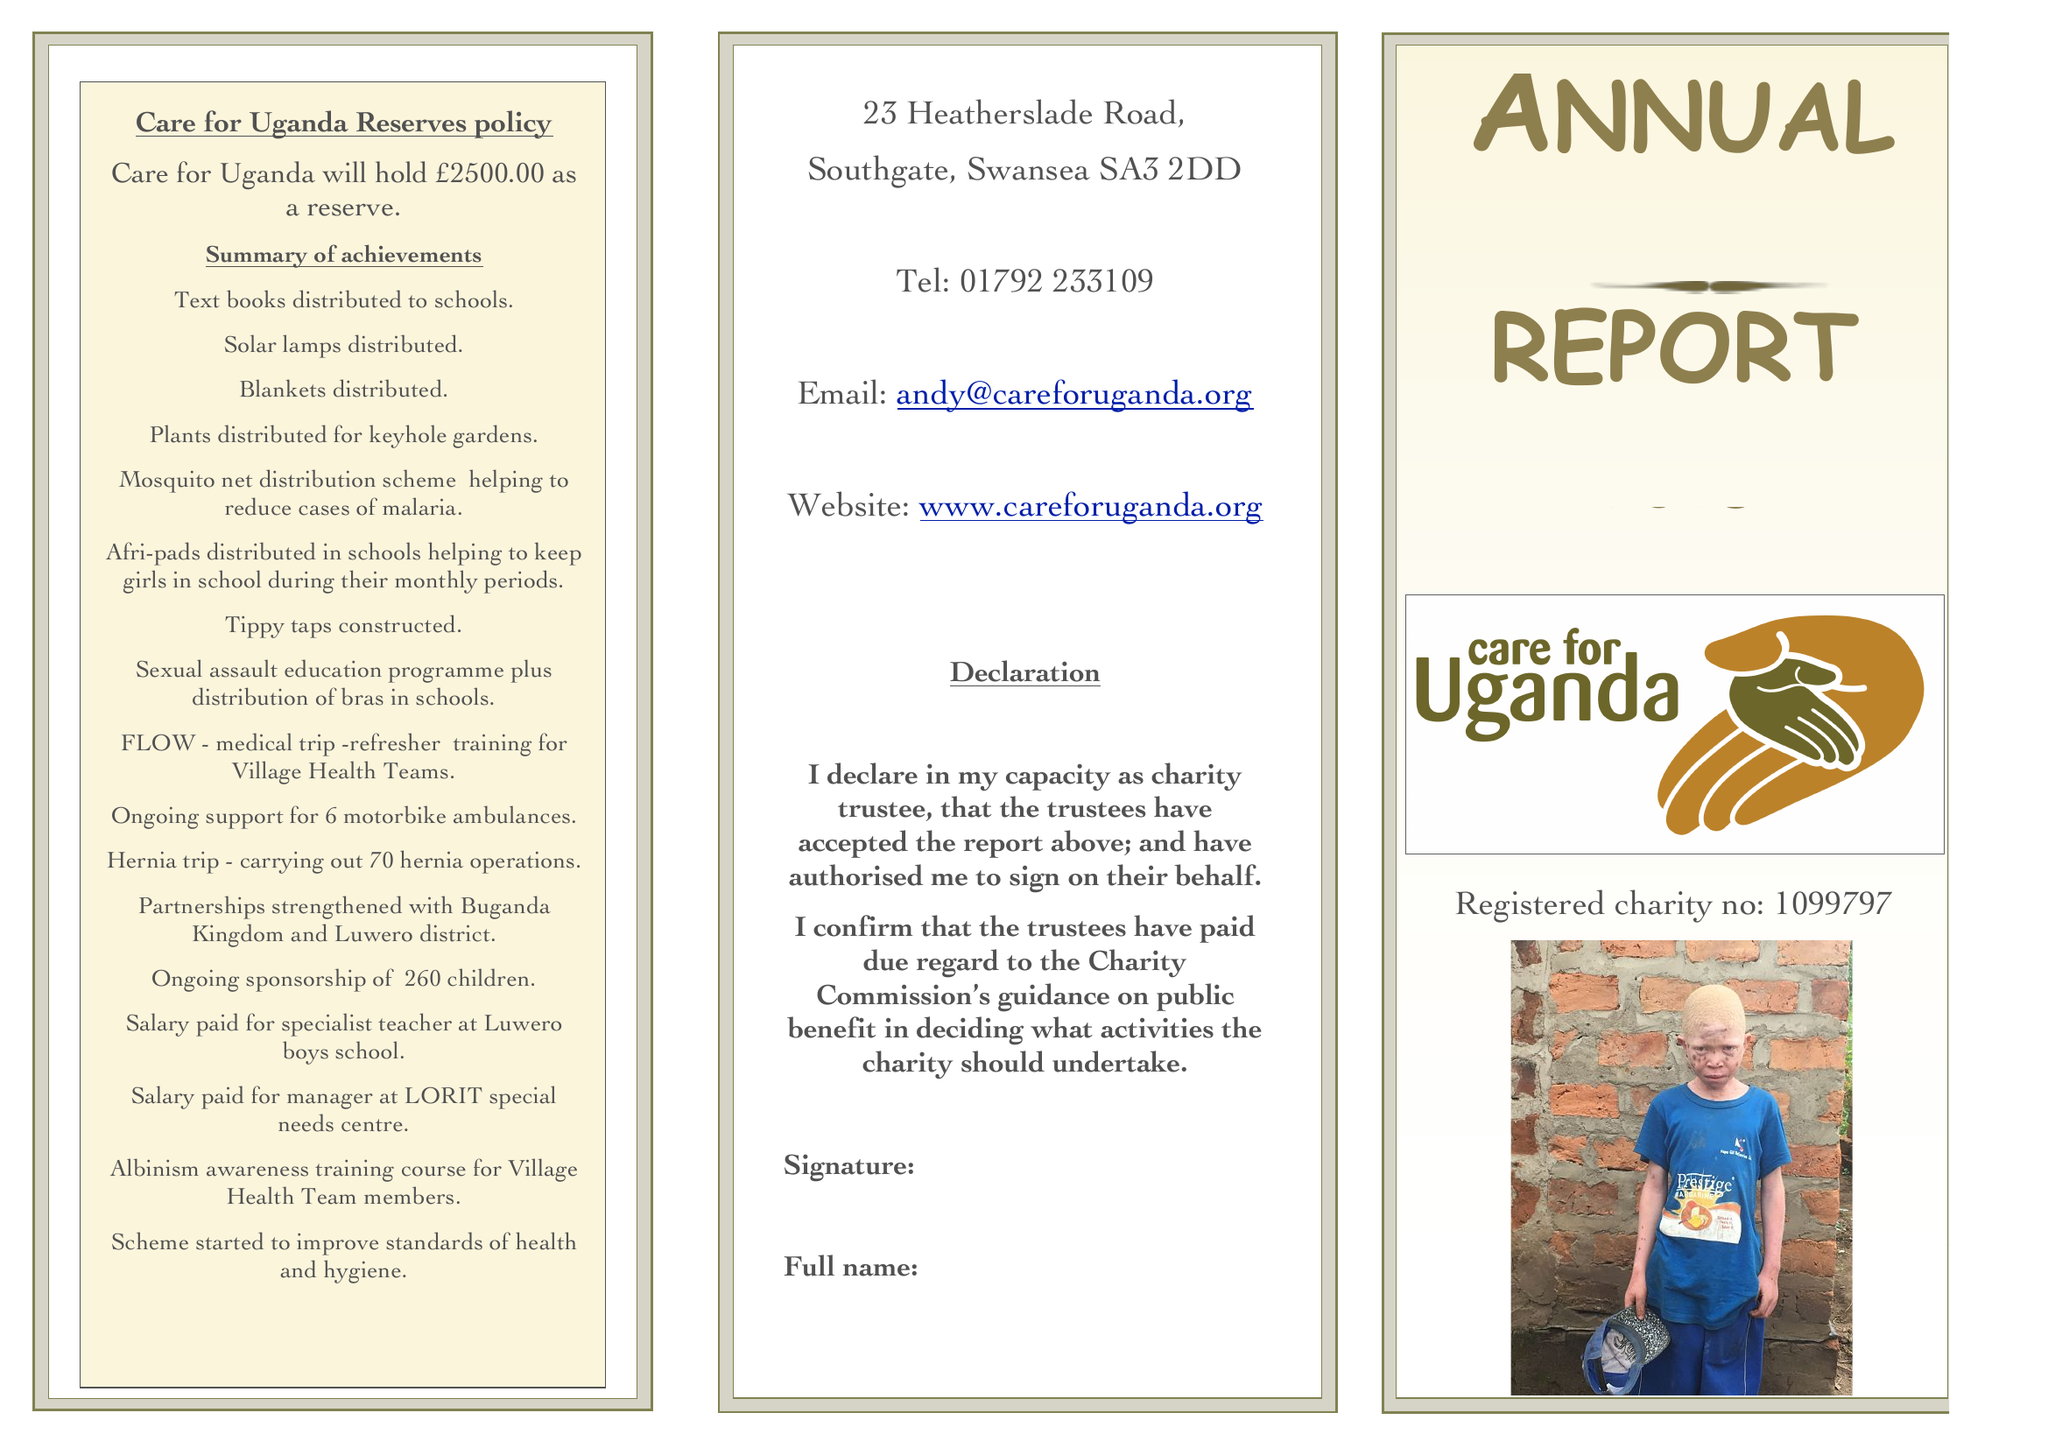What is the value for the address__postcode?
Answer the question using a single word or phrase. SA3 2DD 